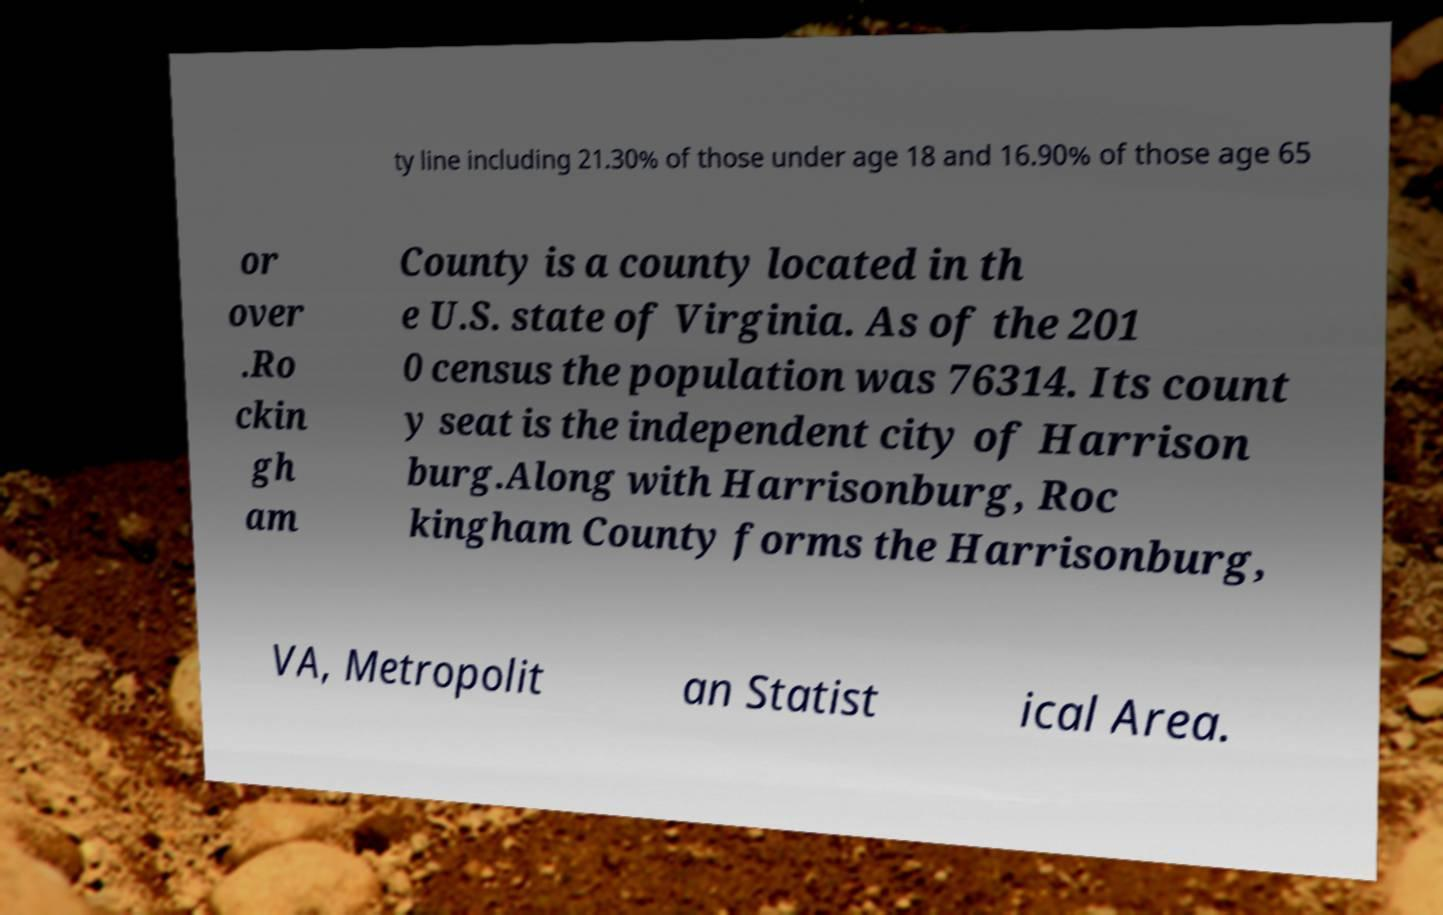Can you read and provide the text displayed in the image?This photo seems to have some interesting text. Can you extract and type it out for me? ty line including 21.30% of those under age 18 and 16.90% of those age 65 or over .Ro ckin gh am County is a county located in th e U.S. state of Virginia. As of the 201 0 census the population was 76314. Its count y seat is the independent city of Harrison burg.Along with Harrisonburg, Roc kingham County forms the Harrisonburg, VA, Metropolit an Statist ical Area. 